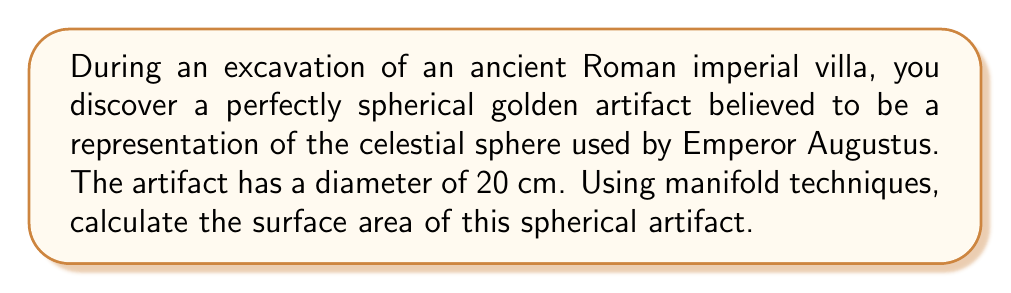Can you answer this question? To calculate the surface area of a spherical artifact using manifold techniques, we'll follow these steps:

1) First, recall that a sphere is a 2-dimensional manifold embedded in 3-dimensional Euclidean space. We can parametrize it using spherical coordinates:

   $$\mathbf{x}(\theta, \phi) = (r\sin\theta\cos\phi, r\sin\theta\sin\phi, r\cos\theta)$$

   where $r$ is the radius, $\theta \in [0, \pi]$ is the polar angle, and $\phi \in [0, 2\pi]$ is the azimuthal angle.

2) The diameter is 20 cm, so the radius $r = 10$ cm.

3) To calculate the surface area, we need to compute the surface integral:

   $$A = \int\int_S dS$$

4) In manifold theory, this is equivalent to integrating the area element:

   $$A = \int_0^\pi \int_0^{2\pi} \sqrt{|g|} \, d\phi \, d\theta$$

   where $g$ is the determinant of the metric tensor.

5) For a sphere, the metric tensor in spherical coordinates is:

   $$g = \begin{pmatrix} 
   r^2 & 0 \\
   0 & r^2\sin^2\theta
   \end{pmatrix}$$

6) The determinant of this tensor is:

   $$|g| = r^4\sin^2\theta$$

7) Therefore, the surface area is:

   $$A = \int_0^\pi \int_0^{2\pi} r^2\sin\theta \, d\phi \, d\theta$$

8) Evaluating this integral:

   $$A = r^2 \int_0^\pi \sin\theta \, d\theta \int_0^{2\pi} d\phi$$
   $$A = r^2 [-\cos\theta]_0^\pi \cdot [2\pi]$$
   $$A = r^2 \cdot 2 \cdot 2\pi = 4\pi r^2$$

9) Substituting $r = 10$ cm:

   $$A = 4\pi (10\text{ cm})^2 = 400\pi \text{ cm}^2$$

Thus, we have derived the well-known formula for the surface area of a sphere using manifold techniques.
Answer: The surface area of the spherical artifact is $400\pi \text{ cm}^2 \approx 1256.64 \text{ cm}^2$. 